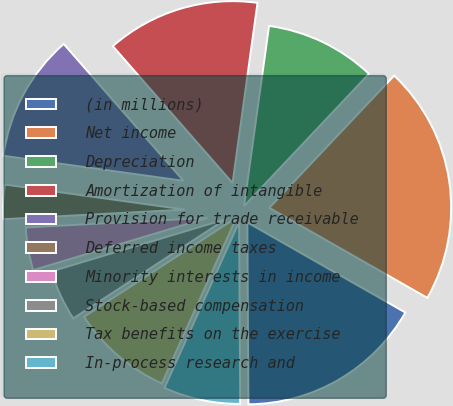Convert chart. <chart><loc_0><loc_0><loc_500><loc_500><pie_chart><fcel>(in millions)<fcel>Net income<fcel>Depreciation<fcel>Amortization of intangible<fcel>Provision for trade receivable<fcel>Deferred income taxes<fcel>Minority interests in income<fcel>Stock-based compensation<fcel>Tax benefits on the exercise<fcel>In-process research and<nl><fcel>16.66%<fcel>21.2%<fcel>9.85%<fcel>13.63%<fcel>11.36%<fcel>3.04%<fcel>3.79%<fcel>4.55%<fcel>9.09%<fcel>6.82%<nl></chart> 